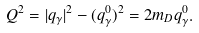Convert formula to latex. <formula><loc_0><loc_0><loc_500><loc_500>Q ^ { 2 } = | { q } _ { \gamma } | ^ { 2 } - ( q _ { \gamma } ^ { 0 } ) ^ { 2 } = 2 m _ { D } q _ { \gamma } ^ { 0 } .</formula> 